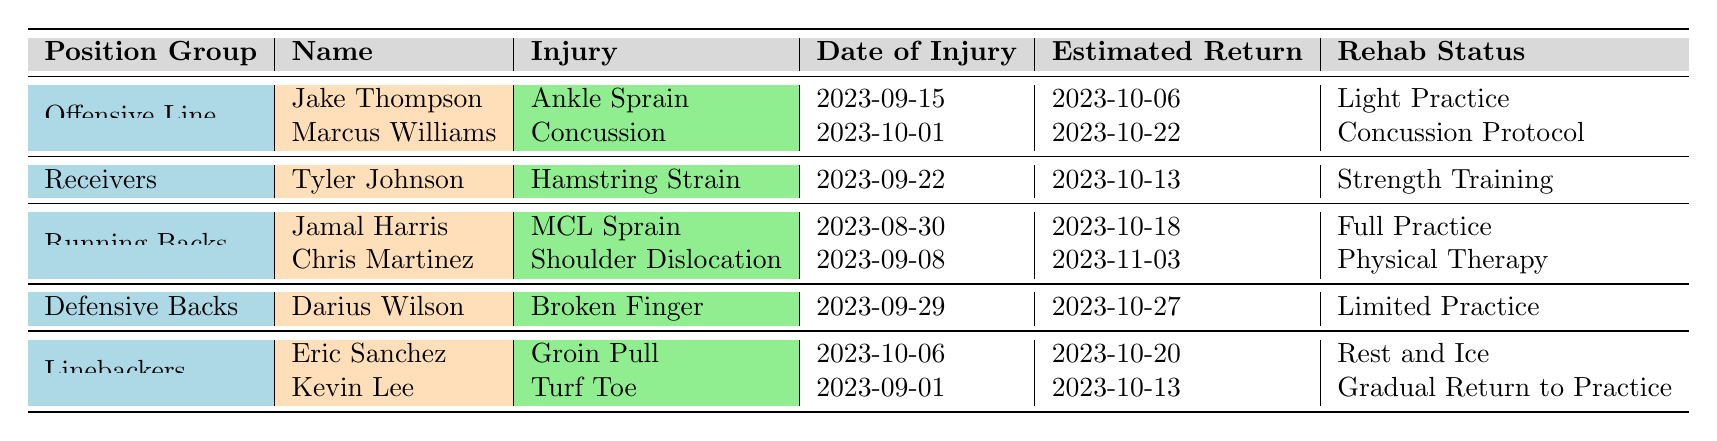What are the estimated return dates for the players in the Offensive Line? The table lists two players in the Offensive Line: Jake Thompson is estimated to return on 2023-10-06 and Marcus Williams on 2023-10-22.
Answer: 2023-10-06 (Jake Thompson), 2023-10-22 (Marcus Williams) Which player has the longest estimated recovery time? By analyzing the estimated return dates, Chris Martinez’s estimated return on 2023-11-03 is the latest among all injured players.
Answer: Chris Martinez Is Tyler Johnson currently in full practice? The table shows that Tyler Johnson is undergoing strength training, which indicates he is not in full practice at this time.
Answer: No How many players in the Running Backs have injuries? The table mentions two players under Running Backs: Jamal Harris and Chris Martinez, thus there are two players with injuries.
Answer: 2 What is the rehab status of the player with the earliest date of injury? The earliest date of injury is for Jamal Harris on 2023-08-30, whose rehab status is Full Practice.
Answer: Full Practice Which position group has only one player listed with an injury? The Receivers position group has only Tyler Johnson listed, making it the position group with a single player on the injury report.
Answer: Receivers Do any players have a rehabilitation status of 'Concussion Protocol'? Yes, Marcus Williams is noted to be on Concussion Protocol according to the table.
Answer: Yes Which player is expected to return the soonest? The earliest estimated return date is for Jake Thompson on 2023-10-06, making him the player expected to return soonest.
Answer: Jake Thompson How many players are estimated to return on or before October 13, 2023? Players estimated to return on or before October 13 are Jake Thompson (10-06), Kevin Lee (10-13), and Tyler Johnson (10-13), totaling three players.
Answer: 3 If Eric Sanchez is currently resting and icing, what date is he expected to return? According to the table, Eric Sanchez has an estimated return date of 2023-10-20.
Answer: 2023-10-20 